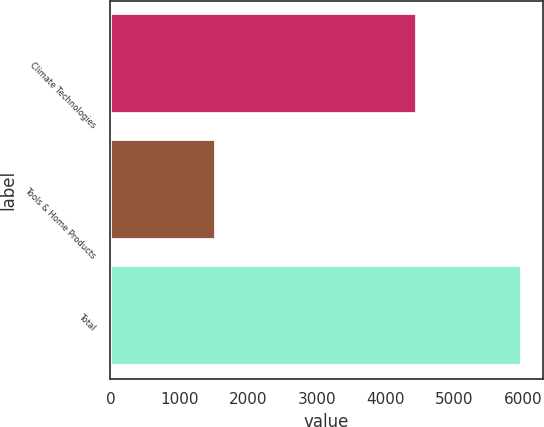<chart> <loc_0><loc_0><loc_500><loc_500><bar_chart><fcel>Climate Technologies<fcel>Tools & Home Products<fcel>Total<nl><fcel>4454<fcel>1528<fcel>5982<nl></chart> 